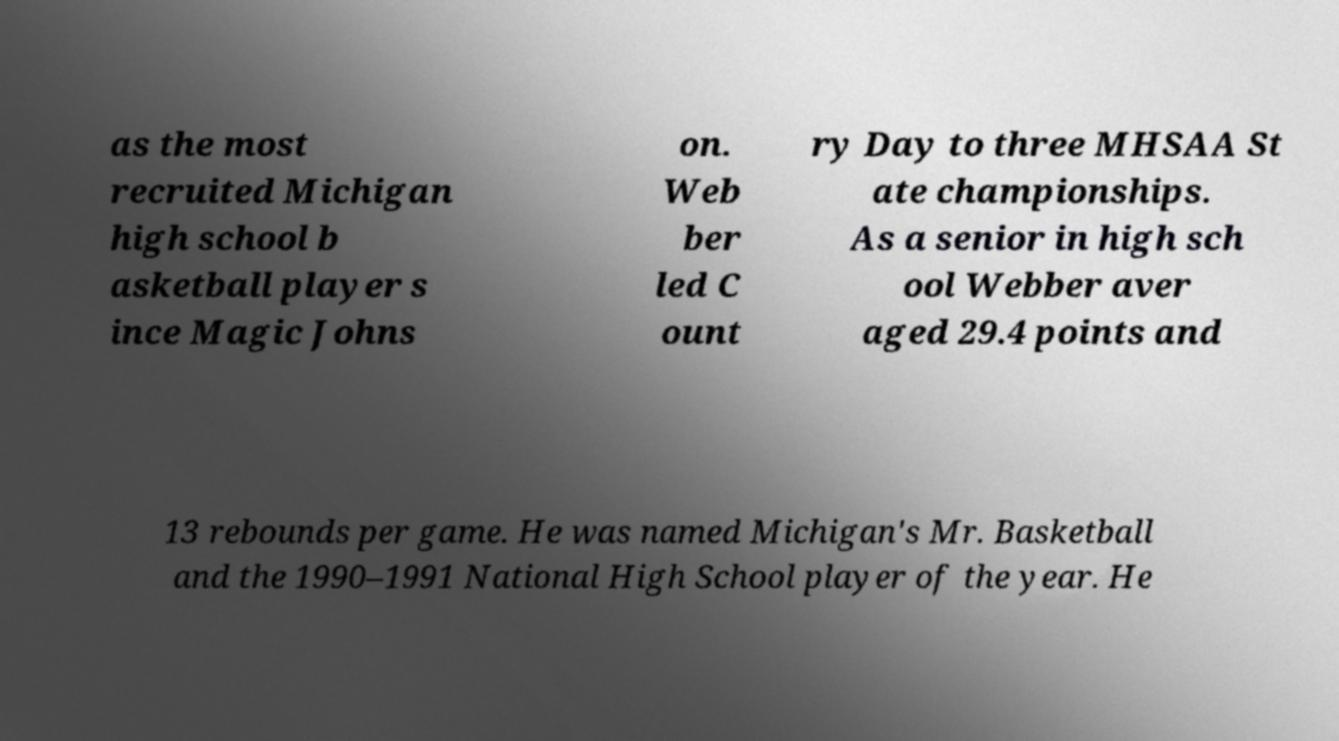Could you assist in decoding the text presented in this image and type it out clearly? as the most recruited Michigan high school b asketball player s ince Magic Johns on. Web ber led C ount ry Day to three MHSAA St ate championships. As a senior in high sch ool Webber aver aged 29.4 points and 13 rebounds per game. He was named Michigan's Mr. Basketball and the 1990–1991 National High School player of the year. He 